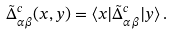Convert formula to latex. <formula><loc_0><loc_0><loc_500><loc_500>\tilde { \Delta } ^ { c } _ { \alpha \beta } ( x , y ) = \langle x | \tilde { \Delta } ^ { c } _ { \alpha \beta } | y \rangle \, .</formula> 